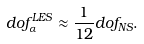<formula> <loc_0><loc_0><loc_500><loc_500>\sl d o f _ { \alpha } ^ { L E S } \approx \frac { 1 } { 1 2 } \sl d o f _ { N S } .</formula> 